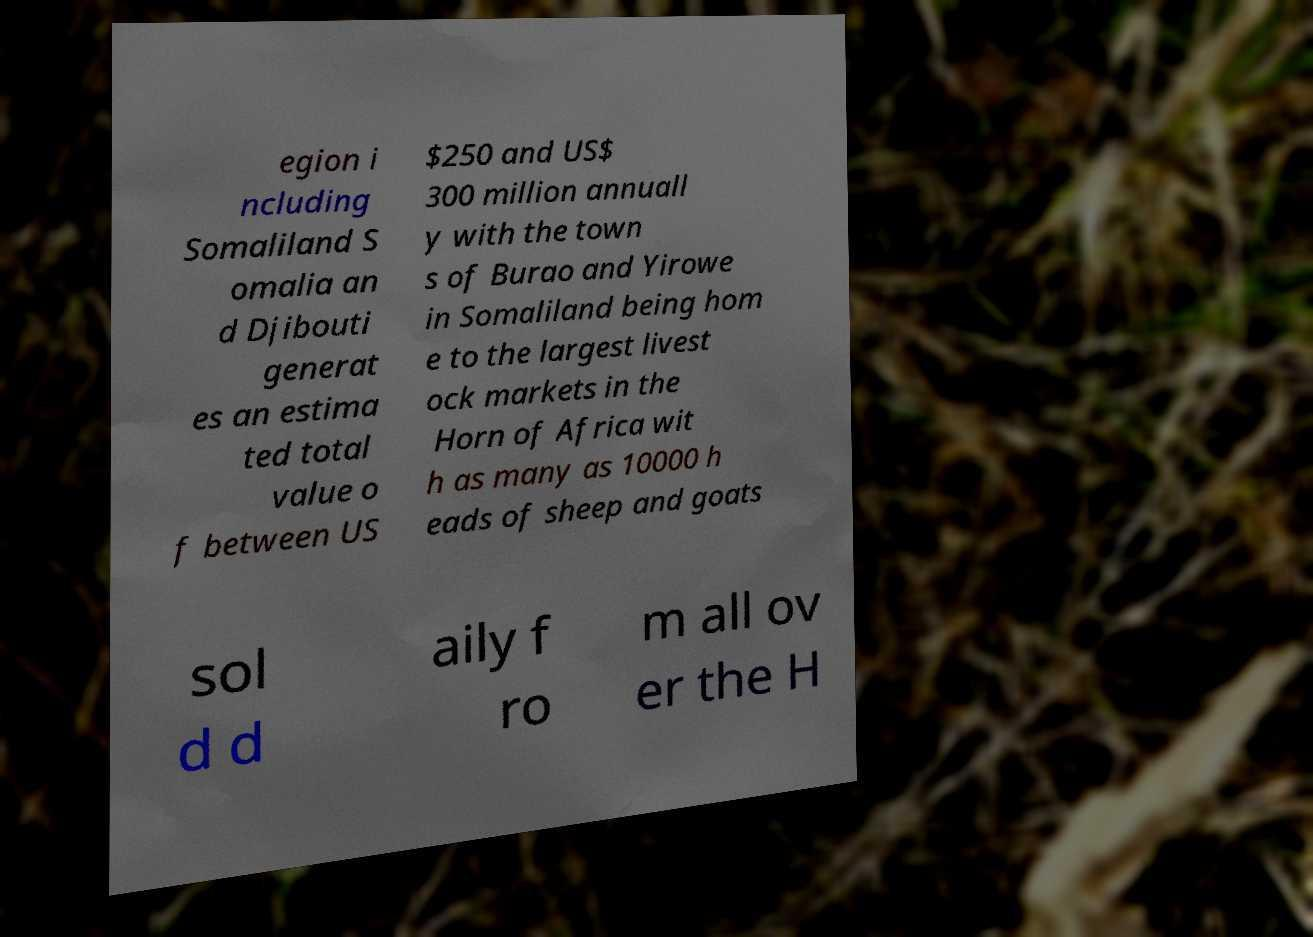Could you assist in decoding the text presented in this image and type it out clearly? egion i ncluding Somaliland S omalia an d Djibouti generat es an estima ted total value o f between US $250 and US$ 300 million annuall y with the town s of Burao and Yirowe in Somaliland being hom e to the largest livest ock markets in the Horn of Africa wit h as many as 10000 h eads of sheep and goats sol d d aily f ro m all ov er the H 